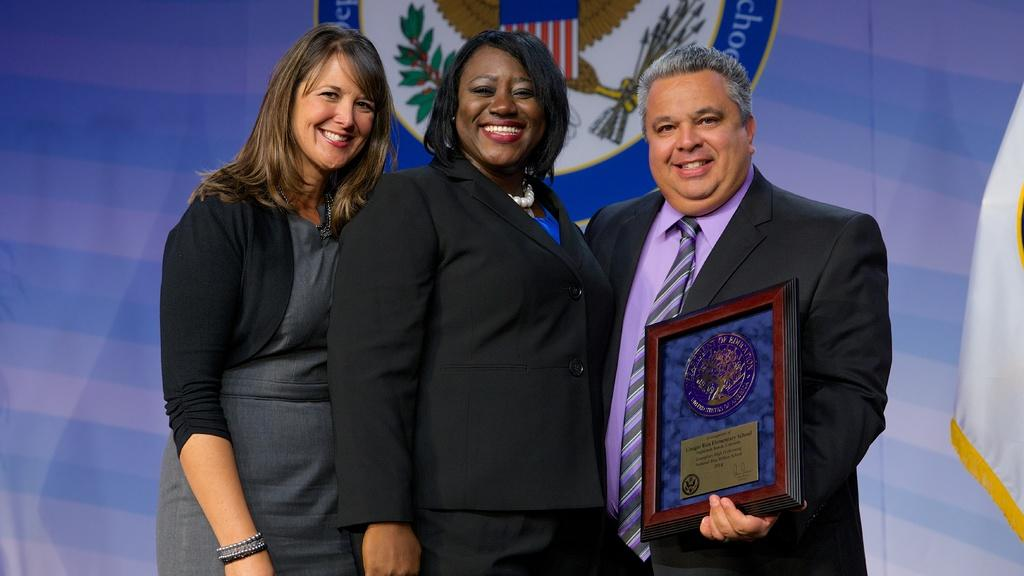How many people are in the image? There are three people in the image. What are the people doing in the image? The people are standing and smiling. Can you describe anything in the background of the image? There is text visible in the background of the image. What type of cannon is being fired in the image? There is no cannon present in the image; it features three people standing and smiling. What day of the week is depicted in the image? The image does not depict a specific day of the week; it only shows three people standing and smiling. 